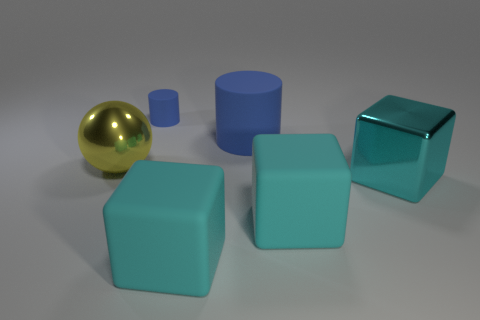Add 3 small cylinders. How many objects exist? 9 Subtract all balls. How many objects are left? 5 Subtract all big cyan matte blocks. How many blocks are left? 1 Subtract 1 cubes. How many cubes are left? 2 Subtract 1 yellow balls. How many objects are left? 5 Subtract all brown balls. Subtract all green cylinders. How many balls are left? 1 Subtract all blue blocks. How many cyan cylinders are left? 0 Subtract all cyan shiny objects. Subtract all large cyan rubber blocks. How many objects are left? 3 Add 4 large matte cubes. How many large matte cubes are left? 6 Add 6 matte blocks. How many matte blocks exist? 8 